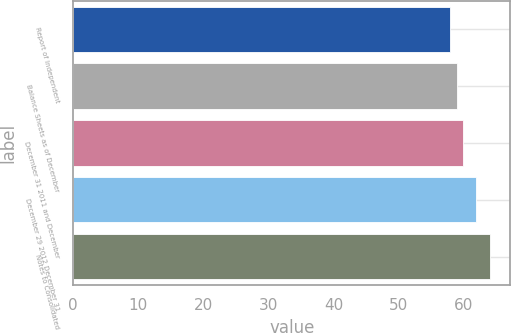Convert chart. <chart><loc_0><loc_0><loc_500><loc_500><bar_chart><fcel>Report of Independent<fcel>Balance Sheets as of December<fcel>December 31 2011 and December<fcel>December 29 2012 December 31<fcel>Notes to Consolidated<nl><fcel>58<fcel>59<fcel>60<fcel>62<fcel>64<nl></chart> 